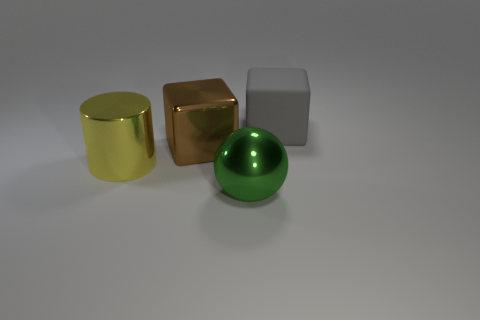Add 3 yellow metallic objects. How many objects exist? 7 Subtract all spheres. How many objects are left? 3 Subtract all green rubber balls. Subtract all large yellow things. How many objects are left? 3 Add 1 big blocks. How many big blocks are left? 3 Add 1 large matte balls. How many large matte balls exist? 1 Subtract 1 yellow cylinders. How many objects are left? 3 